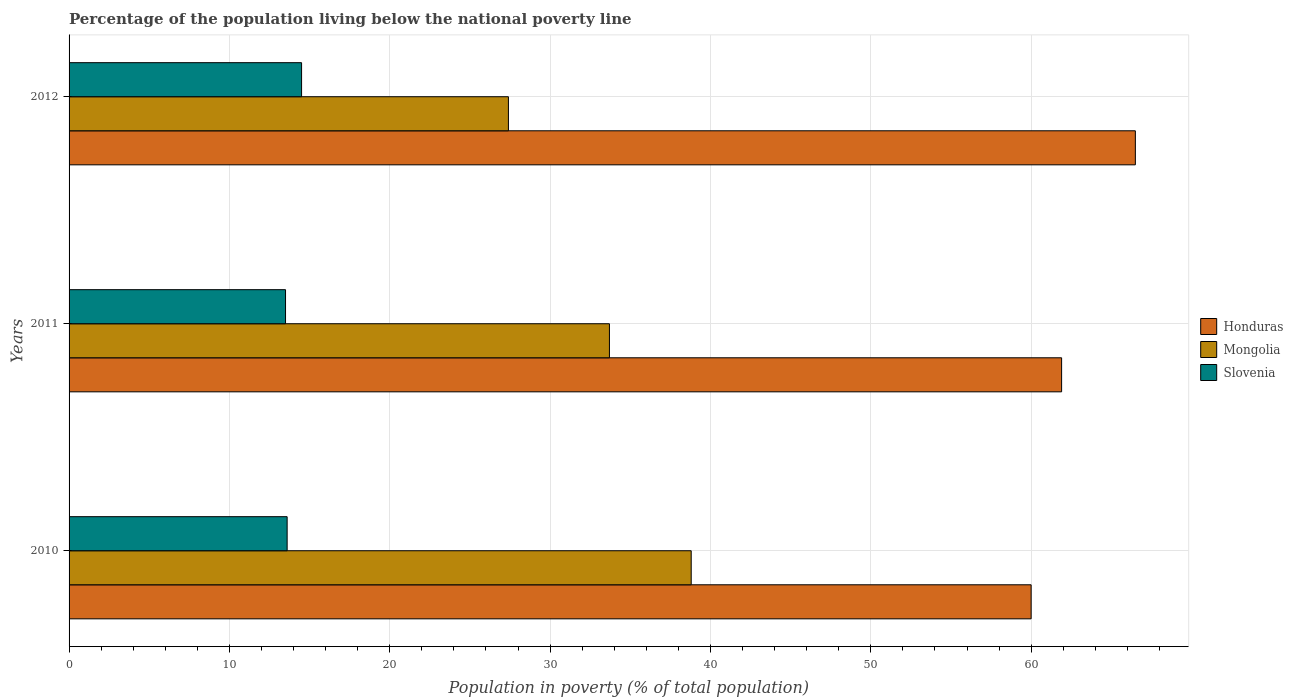How many groups of bars are there?
Make the answer very short. 3. Are the number of bars per tick equal to the number of legend labels?
Provide a short and direct response. Yes. Are the number of bars on each tick of the Y-axis equal?
Give a very brief answer. Yes. How many bars are there on the 2nd tick from the bottom?
Keep it short and to the point. 3. What is the label of the 3rd group of bars from the top?
Provide a short and direct response. 2010. In how many cases, is the number of bars for a given year not equal to the number of legend labels?
Make the answer very short. 0. What is the percentage of the population living below the national poverty line in Honduras in 2011?
Your answer should be very brief. 61.9. Across all years, what is the maximum percentage of the population living below the national poverty line in Honduras?
Ensure brevity in your answer.  66.5. Across all years, what is the minimum percentage of the population living below the national poverty line in Mongolia?
Ensure brevity in your answer.  27.4. In which year was the percentage of the population living below the national poverty line in Mongolia maximum?
Give a very brief answer. 2010. What is the total percentage of the population living below the national poverty line in Slovenia in the graph?
Provide a succinct answer. 41.6. What is the difference between the percentage of the population living below the national poverty line in Slovenia in 2010 and that in 2012?
Offer a very short reply. -0.9. What is the difference between the percentage of the population living below the national poverty line in Honduras in 2011 and the percentage of the population living below the national poverty line in Slovenia in 2012?
Provide a short and direct response. 47.4. What is the average percentage of the population living below the national poverty line in Slovenia per year?
Offer a very short reply. 13.87. In the year 2011, what is the difference between the percentage of the population living below the national poverty line in Mongolia and percentage of the population living below the national poverty line in Slovenia?
Keep it short and to the point. 20.2. What is the ratio of the percentage of the population living below the national poverty line in Honduras in 2010 to that in 2011?
Your response must be concise. 0.97. Is the percentage of the population living below the national poverty line in Slovenia in 2011 less than that in 2012?
Your response must be concise. Yes. What is the difference between the highest and the second highest percentage of the population living below the national poverty line in Mongolia?
Provide a short and direct response. 5.1. What is the difference between the highest and the lowest percentage of the population living below the national poverty line in Honduras?
Your answer should be compact. 6.5. What does the 2nd bar from the top in 2012 represents?
Provide a succinct answer. Mongolia. What does the 3rd bar from the bottom in 2012 represents?
Ensure brevity in your answer.  Slovenia. Does the graph contain any zero values?
Offer a very short reply. No. Where does the legend appear in the graph?
Ensure brevity in your answer.  Center right. How are the legend labels stacked?
Your response must be concise. Vertical. What is the title of the graph?
Provide a short and direct response. Percentage of the population living below the national poverty line. Does "Peru" appear as one of the legend labels in the graph?
Keep it short and to the point. No. What is the label or title of the X-axis?
Your answer should be compact. Population in poverty (% of total population). What is the label or title of the Y-axis?
Give a very brief answer. Years. What is the Population in poverty (% of total population) in Honduras in 2010?
Offer a very short reply. 60. What is the Population in poverty (% of total population) in Mongolia in 2010?
Provide a succinct answer. 38.8. What is the Population in poverty (% of total population) in Slovenia in 2010?
Keep it short and to the point. 13.6. What is the Population in poverty (% of total population) in Honduras in 2011?
Your answer should be very brief. 61.9. What is the Population in poverty (% of total population) in Mongolia in 2011?
Offer a terse response. 33.7. What is the Population in poverty (% of total population) in Honduras in 2012?
Offer a very short reply. 66.5. What is the Population in poverty (% of total population) of Mongolia in 2012?
Provide a succinct answer. 27.4. What is the Population in poverty (% of total population) of Slovenia in 2012?
Your response must be concise. 14.5. Across all years, what is the maximum Population in poverty (% of total population) in Honduras?
Ensure brevity in your answer.  66.5. Across all years, what is the maximum Population in poverty (% of total population) in Mongolia?
Your answer should be compact. 38.8. Across all years, what is the maximum Population in poverty (% of total population) of Slovenia?
Provide a succinct answer. 14.5. Across all years, what is the minimum Population in poverty (% of total population) of Mongolia?
Provide a short and direct response. 27.4. What is the total Population in poverty (% of total population) in Honduras in the graph?
Offer a very short reply. 188.4. What is the total Population in poverty (% of total population) of Mongolia in the graph?
Offer a very short reply. 99.9. What is the total Population in poverty (% of total population) in Slovenia in the graph?
Offer a terse response. 41.6. What is the difference between the Population in poverty (% of total population) of Mongolia in 2010 and that in 2011?
Your response must be concise. 5.1. What is the difference between the Population in poverty (% of total population) of Honduras in 2010 and that in 2012?
Offer a very short reply. -6.5. What is the difference between the Population in poverty (% of total population) of Mongolia in 2010 and that in 2012?
Keep it short and to the point. 11.4. What is the difference between the Population in poverty (% of total population) in Honduras in 2011 and that in 2012?
Provide a succinct answer. -4.6. What is the difference between the Population in poverty (% of total population) of Mongolia in 2011 and that in 2012?
Provide a succinct answer. 6.3. What is the difference between the Population in poverty (% of total population) in Honduras in 2010 and the Population in poverty (% of total population) in Mongolia in 2011?
Ensure brevity in your answer.  26.3. What is the difference between the Population in poverty (% of total population) of Honduras in 2010 and the Population in poverty (% of total population) of Slovenia in 2011?
Your response must be concise. 46.5. What is the difference between the Population in poverty (% of total population) of Mongolia in 2010 and the Population in poverty (% of total population) of Slovenia in 2011?
Ensure brevity in your answer.  25.3. What is the difference between the Population in poverty (% of total population) of Honduras in 2010 and the Population in poverty (% of total population) of Mongolia in 2012?
Offer a terse response. 32.6. What is the difference between the Population in poverty (% of total population) in Honduras in 2010 and the Population in poverty (% of total population) in Slovenia in 2012?
Offer a very short reply. 45.5. What is the difference between the Population in poverty (% of total population) of Mongolia in 2010 and the Population in poverty (% of total population) of Slovenia in 2012?
Your answer should be compact. 24.3. What is the difference between the Population in poverty (% of total population) of Honduras in 2011 and the Population in poverty (% of total population) of Mongolia in 2012?
Ensure brevity in your answer.  34.5. What is the difference between the Population in poverty (% of total population) in Honduras in 2011 and the Population in poverty (% of total population) in Slovenia in 2012?
Offer a terse response. 47.4. What is the average Population in poverty (% of total population) of Honduras per year?
Keep it short and to the point. 62.8. What is the average Population in poverty (% of total population) in Mongolia per year?
Provide a short and direct response. 33.3. What is the average Population in poverty (% of total population) in Slovenia per year?
Ensure brevity in your answer.  13.87. In the year 2010, what is the difference between the Population in poverty (% of total population) in Honduras and Population in poverty (% of total population) in Mongolia?
Offer a very short reply. 21.2. In the year 2010, what is the difference between the Population in poverty (% of total population) of Honduras and Population in poverty (% of total population) of Slovenia?
Keep it short and to the point. 46.4. In the year 2010, what is the difference between the Population in poverty (% of total population) in Mongolia and Population in poverty (% of total population) in Slovenia?
Provide a short and direct response. 25.2. In the year 2011, what is the difference between the Population in poverty (% of total population) in Honduras and Population in poverty (% of total population) in Mongolia?
Give a very brief answer. 28.2. In the year 2011, what is the difference between the Population in poverty (% of total population) of Honduras and Population in poverty (% of total population) of Slovenia?
Provide a succinct answer. 48.4. In the year 2011, what is the difference between the Population in poverty (% of total population) in Mongolia and Population in poverty (% of total population) in Slovenia?
Offer a very short reply. 20.2. In the year 2012, what is the difference between the Population in poverty (% of total population) of Honduras and Population in poverty (% of total population) of Mongolia?
Your answer should be very brief. 39.1. In the year 2012, what is the difference between the Population in poverty (% of total population) of Honduras and Population in poverty (% of total population) of Slovenia?
Provide a short and direct response. 52. In the year 2012, what is the difference between the Population in poverty (% of total population) in Mongolia and Population in poverty (% of total population) in Slovenia?
Offer a very short reply. 12.9. What is the ratio of the Population in poverty (% of total population) in Honduras in 2010 to that in 2011?
Provide a succinct answer. 0.97. What is the ratio of the Population in poverty (% of total population) of Mongolia in 2010 to that in 2011?
Offer a very short reply. 1.15. What is the ratio of the Population in poverty (% of total population) in Slovenia in 2010 to that in 2011?
Offer a terse response. 1.01. What is the ratio of the Population in poverty (% of total population) in Honduras in 2010 to that in 2012?
Make the answer very short. 0.9. What is the ratio of the Population in poverty (% of total population) of Mongolia in 2010 to that in 2012?
Keep it short and to the point. 1.42. What is the ratio of the Population in poverty (% of total population) of Slovenia in 2010 to that in 2012?
Your answer should be compact. 0.94. What is the ratio of the Population in poverty (% of total population) in Honduras in 2011 to that in 2012?
Make the answer very short. 0.93. What is the ratio of the Population in poverty (% of total population) in Mongolia in 2011 to that in 2012?
Offer a terse response. 1.23. What is the difference between the highest and the second highest Population in poverty (% of total population) of Honduras?
Make the answer very short. 4.6. What is the difference between the highest and the lowest Population in poverty (% of total population) of Mongolia?
Keep it short and to the point. 11.4. 